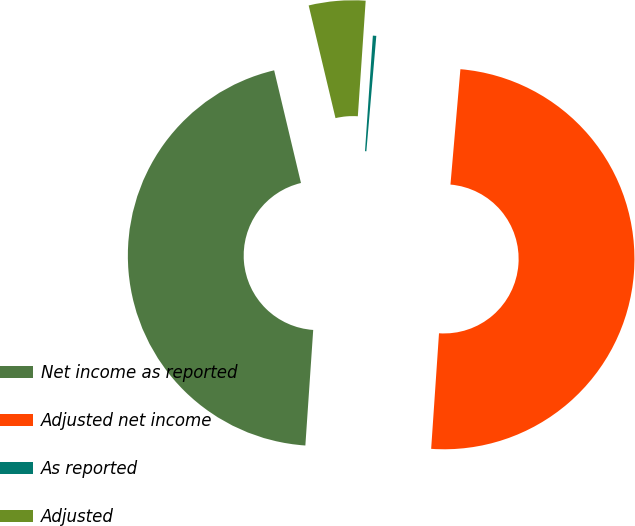Convert chart. <chart><loc_0><loc_0><loc_500><loc_500><pie_chart><fcel>Net income as reported<fcel>Adjusted net income<fcel>As reported<fcel>Adjusted<nl><fcel>45.2%<fcel>49.71%<fcel>0.29%<fcel>4.8%<nl></chart> 